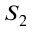<formula> <loc_0><loc_0><loc_500><loc_500>S _ { 2 }</formula> 